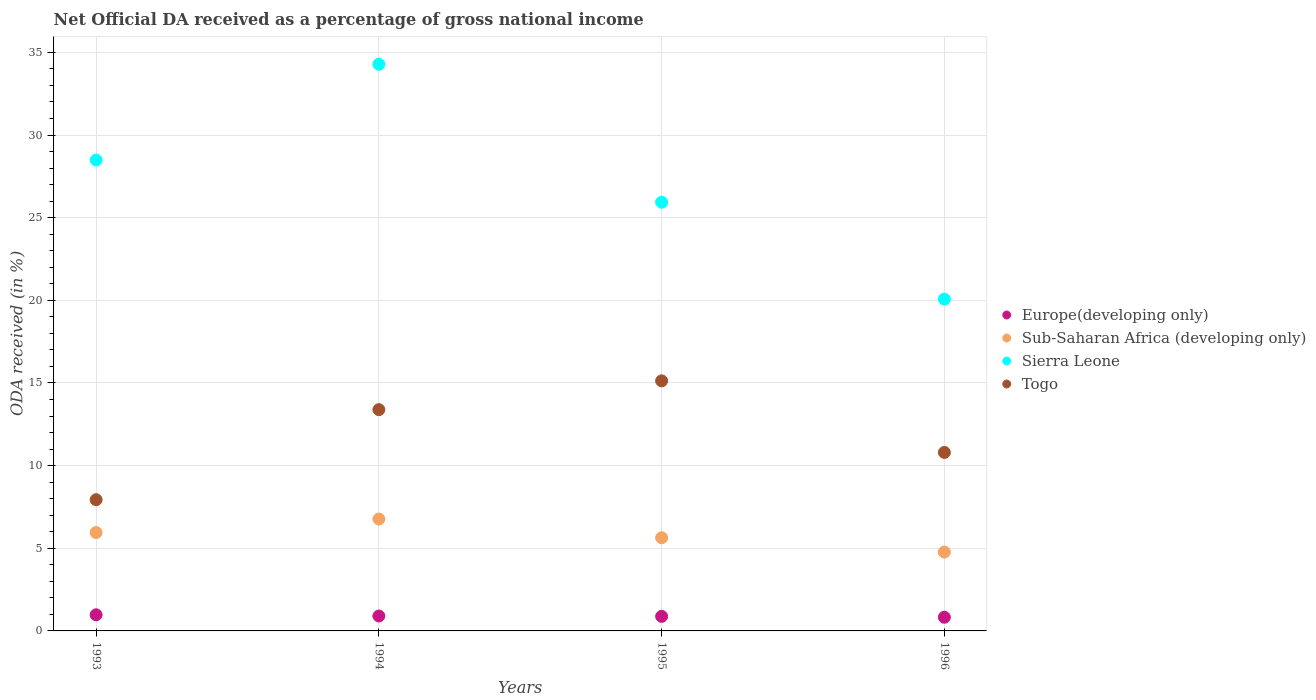How many different coloured dotlines are there?
Provide a short and direct response. 4. Is the number of dotlines equal to the number of legend labels?
Provide a short and direct response. Yes. What is the net official DA received in Sierra Leone in 1996?
Provide a short and direct response. 20.07. Across all years, what is the maximum net official DA received in Togo?
Your response must be concise. 15.13. Across all years, what is the minimum net official DA received in Sub-Saharan Africa (developing only)?
Give a very brief answer. 4.77. What is the total net official DA received in Europe(developing only) in the graph?
Provide a succinct answer. 3.59. What is the difference between the net official DA received in Europe(developing only) in 1995 and that in 1996?
Your answer should be very brief. 0.05. What is the difference between the net official DA received in Sierra Leone in 1995 and the net official DA received in Sub-Saharan Africa (developing only) in 1996?
Provide a succinct answer. 21.16. What is the average net official DA received in Togo per year?
Offer a very short reply. 11.81. In the year 1995, what is the difference between the net official DA received in Europe(developing only) and net official DA received in Sierra Leone?
Keep it short and to the point. -25.05. In how many years, is the net official DA received in Sierra Leone greater than 23 %?
Offer a terse response. 3. What is the ratio of the net official DA received in Togo in 1993 to that in 1994?
Offer a terse response. 0.59. Is the net official DA received in Togo in 1995 less than that in 1996?
Give a very brief answer. No. What is the difference between the highest and the second highest net official DA received in Europe(developing only)?
Give a very brief answer. 0.07. What is the difference between the highest and the lowest net official DA received in Europe(developing only)?
Your answer should be compact. 0.15. Does the net official DA received in Sierra Leone monotonically increase over the years?
Your answer should be compact. No. Is the net official DA received in Europe(developing only) strictly greater than the net official DA received in Togo over the years?
Give a very brief answer. No. Is the net official DA received in Sierra Leone strictly less than the net official DA received in Togo over the years?
Provide a succinct answer. No. How many years are there in the graph?
Your response must be concise. 4. Are the values on the major ticks of Y-axis written in scientific E-notation?
Give a very brief answer. No. Does the graph contain any zero values?
Offer a very short reply. No. Where does the legend appear in the graph?
Your answer should be very brief. Center right. What is the title of the graph?
Provide a succinct answer. Net Official DA received as a percentage of gross national income. Does "Nepal" appear as one of the legend labels in the graph?
Give a very brief answer. No. What is the label or title of the Y-axis?
Give a very brief answer. ODA received (in %). What is the ODA received (in %) of Europe(developing only) in 1993?
Give a very brief answer. 0.98. What is the ODA received (in %) of Sub-Saharan Africa (developing only) in 1993?
Give a very brief answer. 5.95. What is the ODA received (in %) in Sierra Leone in 1993?
Keep it short and to the point. 28.49. What is the ODA received (in %) in Togo in 1993?
Give a very brief answer. 7.94. What is the ODA received (in %) in Europe(developing only) in 1994?
Ensure brevity in your answer.  0.9. What is the ODA received (in %) of Sub-Saharan Africa (developing only) in 1994?
Your answer should be compact. 6.77. What is the ODA received (in %) in Sierra Leone in 1994?
Make the answer very short. 34.28. What is the ODA received (in %) in Togo in 1994?
Your answer should be compact. 13.39. What is the ODA received (in %) of Europe(developing only) in 1995?
Give a very brief answer. 0.88. What is the ODA received (in %) of Sub-Saharan Africa (developing only) in 1995?
Your response must be concise. 5.64. What is the ODA received (in %) of Sierra Leone in 1995?
Provide a short and direct response. 25.93. What is the ODA received (in %) of Togo in 1995?
Provide a short and direct response. 15.13. What is the ODA received (in %) in Europe(developing only) in 1996?
Ensure brevity in your answer.  0.83. What is the ODA received (in %) in Sub-Saharan Africa (developing only) in 1996?
Offer a very short reply. 4.77. What is the ODA received (in %) in Sierra Leone in 1996?
Offer a very short reply. 20.07. What is the ODA received (in %) in Togo in 1996?
Provide a succinct answer. 10.8. Across all years, what is the maximum ODA received (in %) of Europe(developing only)?
Your answer should be very brief. 0.98. Across all years, what is the maximum ODA received (in %) of Sub-Saharan Africa (developing only)?
Provide a succinct answer. 6.77. Across all years, what is the maximum ODA received (in %) of Sierra Leone?
Your answer should be very brief. 34.28. Across all years, what is the maximum ODA received (in %) of Togo?
Make the answer very short. 15.13. Across all years, what is the minimum ODA received (in %) in Europe(developing only)?
Give a very brief answer. 0.83. Across all years, what is the minimum ODA received (in %) of Sub-Saharan Africa (developing only)?
Ensure brevity in your answer.  4.77. Across all years, what is the minimum ODA received (in %) of Sierra Leone?
Your answer should be very brief. 20.07. Across all years, what is the minimum ODA received (in %) of Togo?
Offer a terse response. 7.94. What is the total ODA received (in %) of Europe(developing only) in the graph?
Give a very brief answer. 3.59. What is the total ODA received (in %) in Sub-Saharan Africa (developing only) in the graph?
Make the answer very short. 23.13. What is the total ODA received (in %) in Sierra Leone in the graph?
Make the answer very short. 108.78. What is the total ODA received (in %) in Togo in the graph?
Your answer should be very brief. 47.25. What is the difference between the ODA received (in %) of Europe(developing only) in 1993 and that in 1994?
Offer a very short reply. 0.07. What is the difference between the ODA received (in %) in Sub-Saharan Africa (developing only) in 1993 and that in 1994?
Your answer should be very brief. -0.82. What is the difference between the ODA received (in %) in Sierra Leone in 1993 and that in 1994?
Offer a very short reply. -5.8. What is the difference between the ODA received (in %) in Togo in 1993 and that in 1994?
Your answer should be very brief. -5.45. What is the difference between the ODA received (in %) in Europe(developing only) in 1993 and that in 1995?
Your response must be concise. 0.09. What is the difference between the ODA received (in %) of Sub-Saharan Africa (developing only) in 1993 and that in 1995?
Your answer should be compact. 0.32. What is the difference between the ODA received (in %) in Sierra Leone in 1993 and that in 1995?
Offer a terse response. 2.55. What is the difference between the ODA received (in %) in Togo in 1993 and that in 1995?
Ensure brevity in your answer.  -7.19. What is the difference between the ODA received (in %) of Europe(developing only) in 1993 and that in 1996?
Ensure brevity in your answer.  0.15. What is the difference between the ODA received (in %) in Sub-Saharan Africa (developing only) in 1993 and that in 1996?
Provide a succinct answer. 1.18. What is the difference between the ODA received (in %) of Sierra Leone in 1993 and that in 1996?
Your answer should be very brief. 8.41. What is the difference between the ODA received (in %) in Togo in 1993 and that in 1996?
Keep it short and to the point. -2.86. What is the difference between the ODA received (in %) in Europe(developing only) in 1994 and that in 1995?
Provide a short and direct response. 0.02. What is the difference between the ODA received (in %) of Sub-Saharan Africa (developing only) in 1994 and that in 1995?
Offer a very short reply. 1.13. What is the difference between the ODA received (in %) of Sierra Leone in 1994 and that in 1995?
Your response must be concise. 8.35. What is the difference between the ODA received (in %) in Togo in 1994 and that in 1995?
Ensure brevity in your answer.  -1.74. What is the difference between the ODA received (in %) in Europe(developing only) in 1994 and that in 1996?
Your response must be concise. 0.08. What is the difference between the ODA received (in %) in Sub-Saharan Africa (developing only) in 1994 and that in 1996?
Your answer should be compact. 2. What is the difference between the ODA received (in %) in Sierra Leone in 1994 and that in 1996?
Provide a succinct answer. 14.21. What is the difference between the ODA received (in %) of Togo in 1994 and that in 1996?
Your answer should be very brief. 2.59. What is the difference between the ODA received (in %) in Europe(developing only) in 1995 and that in 1996?
Keep it short and to the point. 0.05. What is the difference between the ODA received (in %) of Sub-Saharan Africa (developing only) in 1995 and that in 1996?
Provide a succinct answer. 0.87. What is the difference between the ODA received (in %) of Sierra Leone in 1995 and that in 1996?
Offer a terse response. 5.86. What is the difference between the ODA received (in %) in Togo in 1995 and that in 1996?
Offer a terse response. 4.33. What is the difference between the ODA received (in %) in Europe(developing only) in 1993 and the ODA received (in %) in Sub-Saharan Africa (developing only) in 1994?
Give a very brief answer. -5.79. What is the difference between the ODA received (in %) of Europe(developing only) in 1993 and the ODA received (in %) of Sierra Leone in 1994?
Offer a very short reply. -33.31. What is the difference between the ODA received (in %) of Europe(developing only) in 1993 and the ODA received (in %) of Togo in 1994?
Provide a succinct answer. -12.41. What is the difference between the ODA received (in %) in Sub-Saharan Africa (developing only) in 1993 and the ODA received (in %) in Sierra Leone in 1994?
Provide a succinct answer. -28.33. What is the difference between the ODA received (in %) of Sub-Saharan Africa (developing only) in 1993 and the ODA received (in %) of Togo in 1994?
Provide a succinct answer. -7.43. What is the difference between the ODA received (in %) in Sierra Leone in 1993 and the ODA received (in %) in Togo in 1994?
Provide a succinct answer. 15.1. What is the difference between the ODA received (in %) of Europe(developing only) in 1993 and the ODA received (in %) of Sub-Saharan Africa (developing only) in 1995?
Your answer should be very brief. -4.66. What is the difference between the ODA received (in %) of Europe(developing only) in 1993 and the ODA received (in %) of Sierra Leone in 1995?
Offer a terse response. -24.96. What is the difference between the ODA received (in %) in Europe(developing only) in 1993 and the ODA received (in %) in Togo in 1995?
Offer a terse response. -14.15. What is the difference between the ODA received (in %) of Sub-Saharan Africa (developing only) in 1993 and the ODA received (in %) of Sierra Leone in 1995?
Your response must be concise. -19.98. What is the difference between the ODA received (in %) in Sub-Saharan Africa (developing only) in 1993 and the ODA received (in %) in Togo in 1995?
Your answer should be very brief. -9.17. What is the difference between the ODA received (in %) in Sierra Leone in 1993 and the ODA received (in %) in Togo in 1995?
Offer a very short reply. 13.36. What is the difference between the ODA received (in %) in Europe(developing only) in 1993 and the ODA received (in %) in Sub-Saharan Africa (developing only) in 1996?
Make the answer very short. -3.79. What is the difference between the ODA received (in %) in Europe(developing only) in 1993 and the ODA received (in %) in Sierra Leone in 1996?
Provide a succinct answer. -19.1. What is the difference between the ODA received (in %) in Europe(developing only) in 1993 and the ODA received (in %) in Togo in 1996?
Make the answer very short. -9.82. What is the difference between the ODA received (in %) of Sub-Saharan Africa (developing only) in 1993 and the ODA received (in %) of Sierra Leone in 1996?
Offer a terse response. -14.12. What is the difference between the ODA received (in %) of Sub-Saharan Africa (developing only) in 1993 and the ODA received (in %) of Togo in 1996?
Ensure brevity in your answer.  -4.85. What is the difference between the ODA received (in %) of Sierra Leone in 1993 and the ODA received (in %) of Togo in 1996?
Offer a very short reply. 17.69. What is the difference between the ODA received (in %) in Europe(developing only) in 1994 and the ODA received (in %) in Sub-Saharan Africa (developing only) in 1995?
Ensure brevity in your answer.  -4.73. What is the difference between the ODA received (in %) in Europe(developing only) in 1994 and the ODA received (in %) in Sierra Leone in 1995?
Provide a short and direct response. -25.03. What is the difference between the ODA received (in %) in Europe(developing only) in 1994 and the ODA received (in %) in Togo in 1995?
Keep it short and to the point. -14.22. What is the difference between the ODA received (in %) in Sub-Saharan Africa (developing only) in 1994 and the ODA received (in %) in Sierra Leone in 1995?
Keep it short and to the point. -19.17. What is the difference between the ODA received (in %) of Sub-Saharan Africa (developing only) in 1994 and the ODA received (in %) of Togo in 1995?
Keep it short and to the point. -8.36. What is the difference between the ODA received (in %) in Sierra Leone in 1994 and the ODA received (in %) in Togo in 1995?
Offer a very short reply. 19.15. What is the difference between the ODA received (in %) of Europe(developing only) in 1994 and the ODA received (in %) of Sub-Saharan Africa (developing only) in 1996?
Provide a succinct answer. -3.87. What is the difference between the ODA received (in %) of Europe(developing only) in 1994 and the ODA received (in %) of Sierra Leone in 1996?
Make the answer very short. -19.17. What is the difference between the ODA received (in %) of Europe(developing only) in 1994 and the ODA received (in %) of Togo in 1996?
Your response must be concise. -9.9. What is the difference between the ODA received (in %) of Sub-Saharan Africa (developing only) in 1994 and the ODA received (in %) of Sierra Leone in 1996?
Make the answer very short. -13.3. What is the difference between the ODA received (in %) of Sub-Saharan Africa (developing only) in 1994 and the ODA received (in %) of Togo in 1996?
Your response must be concise. -4.03. What is the difference between the ODA received (in %) of Sierra Leone in 1994 and the ODA received (in %) of Togo in 1996?
Your answer should be compact. 23.48. What is the difference between the ODA received (in %) in Europe(developing only) in 1995 and the ODA received (in %) in Sub-Saharan Africa (developing only) in 1996?
Your response must be concise. -3.89. What is the difference between the ODA received (in %) of Europe(developing only) in 1995 and the ODA received (in %) of Sierra Leone in 1996?
Provide a succinct answer. -19.19. What is the difference between the ODA received (in %) in Europe(developing only) in 1995 and the ODA received (in %) in Togo in 1996?
Offer a very short reply. -9.92. What is the difference between the ODA received (in %) in Sub-Saharan Africa (developing only) in 1995 and the ODA received (in %) in Sierra Leone in 1996?
Ensure brevity in your answer.  -14.44. What is the difference between the ODA received (in %) of Sub-Saharan Africa (developing only) in 1995 and the ODA received (in %) of Togo in 1996?
Make the answer very short. -5.16. What is the difference between the ODA received (in %) of Sierra Leone in 1995 and the ODA received (in %) of Togo in 1996?
Offer a terse response. 15.14. What is the average ODA received (in %) of Europe(developing only) per year?
Make the answer very short. 0.9. What is the average ODA received (in %) of Sub-Saharan Africa (developing only) per year?
Keep it short and to the point. 5.78. What is the average ODA received (in %) in Sierra Leone per year?
Offer a terse response. 27.19. What is the average ODA received (in %) of Togo per year?
Your answer should be very brief. 11.81. In the year 1993, what is the difference between the ODA received (in %) of Europe(developing only) and ODA received (in %) of Sub-Saharan Africa (developing only)?
Offer a very short reply. -4.98. In the year 1993, what is the difference between the ODA received (in %) in Europe(developing only) and ODA received (in %) in Sierra Leone?
Offer a very short reply. -27.51. In the year 1993, what is the difference between the ODA received (in %) of Europe(developing only) and ODA received (in %) of Togo?
Provide a succinct answer. -6.96. In the year 1993, what is the difference between the ODA received (in %) in Sub-Saharan Africa (developing only) and ODA received (in %) in Sierra Leone?
Your answer should be very brief. -22.53. In the year 1993, what is the difference between the ODA received (in %) of Sub-Saharan Africa (developing only) and ODA received (in %) of Togo?
Ensure brevity in your answer.  -1.98. In the year 1993, what is the difference between the ODA received (in %) in Sierra Leone and ODA received (in %) in Togo?
Make the answer very short. 20.55. In the year 1994, what is the difference between the ODA received (in %) in Europe(developing only) and ODA received (in %) in Sub-Saharan Africa (developing only)?
Give a very brief answer. -5.87. In the year 1994, what is the difference between the ODA received (in %) in Europe(developing only) and ODA received (in %) in Sierra Leone?
Provide a short and direct response. -33.38. In the year 1994, what is the difference between the ODA received (in %) in Europe(developing only) and ODA received (in %) in Togo?
Give a very brief answer. -12.48. In the year 1994, what is the difference between the ODA received (in %) of Sub-Saharan Africa (developing only) and ODA received (in %) of Sierra Leone?
Give a very brief answer. -27.51. In the year 1994, what is the difference between the ODA received (in %) in Sub-Saharan Africa (developing only) and ODA received (in %) in Togo?
Your answer should be compact. -6.62. In the year 1994, what is the difference between the ODA received (in %) of Sierra Leone and ODA received (in %) of Togo?
Keep it short and to the point. 20.89. In the year 1995, what is the difference between the ODA received (in %) in Europe(developing only) and ODA received (in %) in Sub-Saharan Africa (developing only)?
Keep it short and to the point. -4.75. In the year 1995, what is the difference between the ODA received (in %) of Europe(developing only) and ODA received (in %) of Sierra Leone?
Give a very brief answer. -25.05. In the year 1995, what is the difference between the ODA received (in %) of Europe(developing only) and ODA received (in %) of Togo?
Make the answer very short. -14.25. In the year 1995, what is the difference between the ODA received (in %) in Sub-Saharan Africa (developing only) and ODA received (in %) in Sierra Leone?
Give a very brief answer. -20.3. In the year 1995, what is the difference between the ODA received (in %) of Sub-Saharan Africa (developing only) and ODA received (in %) of Togo?
Your response must be concise. -9.49. In the year 1995, what is the difference between the ODA received (in %) of Sierra Leone and ODA received (in %) of Togo?
Keep it short and to the point. 10.81. In the year 1996, what is the difference between the ODA received (in %) in Europe(developing only) and ODA received (in %) in Sub-Saharan Africa (developing only)?
Your answer should be very brief. -3.94. In the year 1996, what is the difference between the ODA received (in %) of Europe(developing only) and ODA received (in %) of Sierra Leone?
Make the answer very short. -19.25. In the year 1996, what is the difference between the ODA received (in %) in Europe(developing only) and ODA received (in %) in Togo?
Your answer should be very brief. -9.97. In the year 1996, what is the difference between the ODA received (in %) in Sub-Saharan Africa (developing only) and ODA received (in %) in Sierra Leone?
Make the answer very short. -15.3. In the year 1996, what is the difference between the ODA received (in %) of Sub-Saharan Africa (developing only) and ODA received (in %) of Togo?
Offer a terse response. -6.03. In the year 1996, what is the difference between the ODA received (in %) of Sierra Leone and ODA received (in %) of Togo?
Make the answer very short. 9.28. What is the ratio of the ODA received (in %) of Europe(developing only) in 1993 to that in 1994?
Keep it short and to the point. 1.08. What is the ratio of the ODA received (in %) in Sub-Saharan Africa (developing only) in 1993 to that in 1994?
Your response must be concise. 0.88. What is the ratio of the ODA received (in %) of Sierra Leone in 1993 to that in 1994?
Keep it short and to the point. 0.83. What is the ratio of the ODA received (in %) in Togo in 1993 to that in 1994?
Provide a succinct answer. 0.59. What is the ratio of the ODA received (in %) in Europe(developing only) in 1993 to that in 1995?
Offer a very short reply. 1.11. What is the ratio of the ODA received (in %) in Sub-Saharan Africa (developing only) in 1993 to that in 1995?
Provide a succinct answer. 1.06. What is the ratio of the ODA received (in %) in Sierra Leone in 1993 to that in 1995?
Provide a short and direct response. 1.1. What is the ratio of the ODA received (in %) in Togo in 1993 to that in 1995?
Keep it short and to the point. 0.52. What is the ratio of the ODA received (in %) in Europe(developing only) in 1993 to that in 1996?
Provide a succinct answer. 1.18. What is the ratio of the ODA received (in %) of Sub-Saharan Africa (developing only) in 1993 to that in 1996?
Offer a terse response. 1.25. What is the ratio of the ODA received (in %) in Sierra Leone in 1993 to that in 1996?
Provide a short and direct response. 1.42. What is the ratio of the ODA received (in %) of Togo in 1993 to that in 1996?
Offer a very short reply. 0.73. What is the ratio of the ODA received (in %) in Europe(developing only) in 1994 to that in 1995?
Ensure brevity in your answer.  1.02. What is the ratio of the ODA received (in %) of Sub-Saharan Africa (developing only) in 1994 to that in 1995?
Offer a very short reply. 1.2. What is the ratio of the ODA received (in %) of Sierra Leone in 1994 to that in 1995?
Keep it short and to the point. 1.32. What is the ratio of the ODA received (in %) of Togo in 1994 to that in 1995?
Your answer should be compact. 0.88. What is the ratio of the ODA received (in %) of Europe(developing only) in 1994 to that in 1996?
Your answer should be very brief. 1.09. What is the ratio of the ODA received (in %) in Sub-Saharan Africa (developing only) in 1994 to that in 1996?
Ensure brevity in your answer.  1.42. What is the ratio of the ODA received (in %) in Sierra Leone in 1994 to that in 1996?
Keep it short and to the point. 1.71. What is the ratio of the ODA received (in %) in Togo in 1994 to that in 1996?
Ensure brevity in your answer.  1.24. What is the ratio of the ODA received (in %) in Europe(developing only) in 1995 to that in 1996?
Offer a terse response. 1.06. What is the ratio of the ODA received (in %) in Sub-Saharan Africa (developing only) in 1995 to that in 1996?
Provide a short and direct response. 1.18. What is the ratio of the ODA received (in %) in Sierra Leone in 1995 to that in 1996?
Offer a very short reply. 1.29. What is the ratio of the ODA received (in %) of Togo in 1995 to that in 1996?
Make the answer very short. 1.4. What is the difference between the highest and the second highest ODA received (in %) of Europe(developing only)?
Give a very brief answer. 0.07. What is the difference between the highest and the second highest ODA received (in %) of Sub-Saharan Africa (developing only)?
Ensure brevity in your answer.  0.82. What is the difference between the highest and the second highest ODA received (in %) in Sierra Leone?
Your answer should be very brief. 5.8. What is the difference between the highest and the second highest ODA received (in %) in Togo?
Your answer should be very brief. 1.74. What is the difference between the highest and the lowest ODA received (in %) of Europe(developing only)?
Your answer should be compact. 0.15. What is the difference between the highest and the lowest ODA received (in %) of Sub-Saharan Africa (developing only)?
Make the answer very short. 2. What is the difference between the highest and the lowest ODA received (in %) in Sierra Leone?
Give a very brief answer. 14.21. What is the difference between the highest and the lowest ODA received (in %) in Togo?
Your answer should be compact. 7.19. 